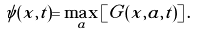<formula> <loc_0><loc_0><loc_500><loc_500>\psi ( x , t ) = \max _ { a } \left [ G ( x , a , t ) \right ] .</formula> 